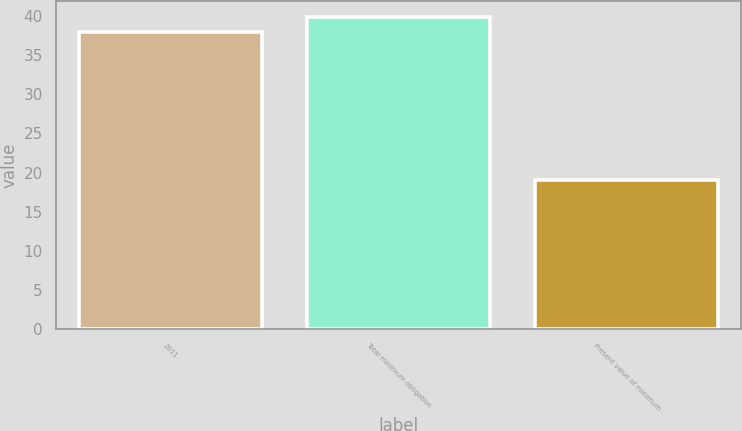<chart> <loc_0><loc_0><loc_500><loc_500><bar_chart><fcel>2011<fcel>Total minimum obligation<fcel>Present value of minimum<nl><fcel>38<fcel>39.9<fcel>19<nl></chart> 